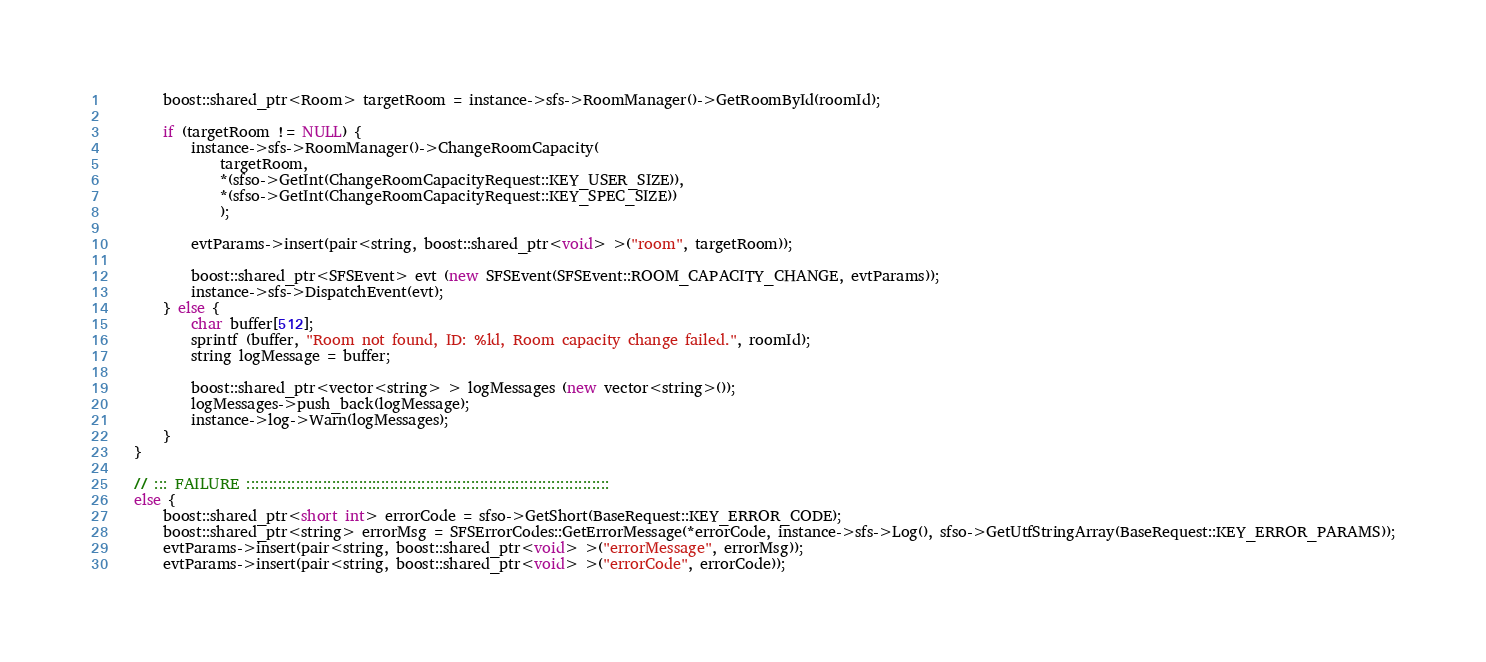<code> <loc_0><loc_0><loc_500><loc_500><_C++_>		boost::shared_ptr<Room> targetRoom = instance->sfs->RoomManager()->GetRoomById(roomId);

		if (targetRoom != NULL) {
			instance->sfs->RoomManager()->ChangeRoomCapacity(
				targetRoom,
				*(sfso->GetInt(ChangeRoomCapacityRequest::KEY_USER_SIZE)), 
				*(sfso->GetInt(ChangeRoomCapacityRequest::KEY_SPEC_SIZE))
				);

			evtParams->insert(pair<string, boost::shared_ptr<void> >("room", targetRoom));

			boost::shared_ptr<SFSEvent> evt (new SFSEvent(SFSEvent::ROOM_CAPACITY_CHANGE, evtParams));
			instance->sfs->DispatchEvent(evt);
		} else {
			char buffer[512];
			sprintf (buffer, "Room not found, ID: %ld, Room capacity change failed.", roomId);
			string logMessage = buffer;

			boost::shared_ptr<vector<string> > logMessages (new vector<string>());
			logMessages->push_back(logMessage);
			instance->log->Warn(logMessages);
		}
	}

	// ::: FAILURE :::::::::::::::::::::::::::::::::::::::::::::::::::::::::::::::::::::::::::::::::
	else {
		boost::shared_ptr<short int> errorCode = sfso->GetShort(BaseRequest::KEY_ERROR_CODE);
		boost::shared_ptr<string> errorMsg = SFSErrorCodes::GetErrorMessage(*errorCode, instance->sfs->Log(), sfso->GetUtfStringArray(BaseRequest::KEY_ERROR_PARAMS));
		evtParams->insert(pair<string, boost::shared_ptr<void> >("errorMessage", errorMsg));
		evtParams->insert(pair<string, boost::shared_ptr<void> >("errorCode", errorCode));
</code> 